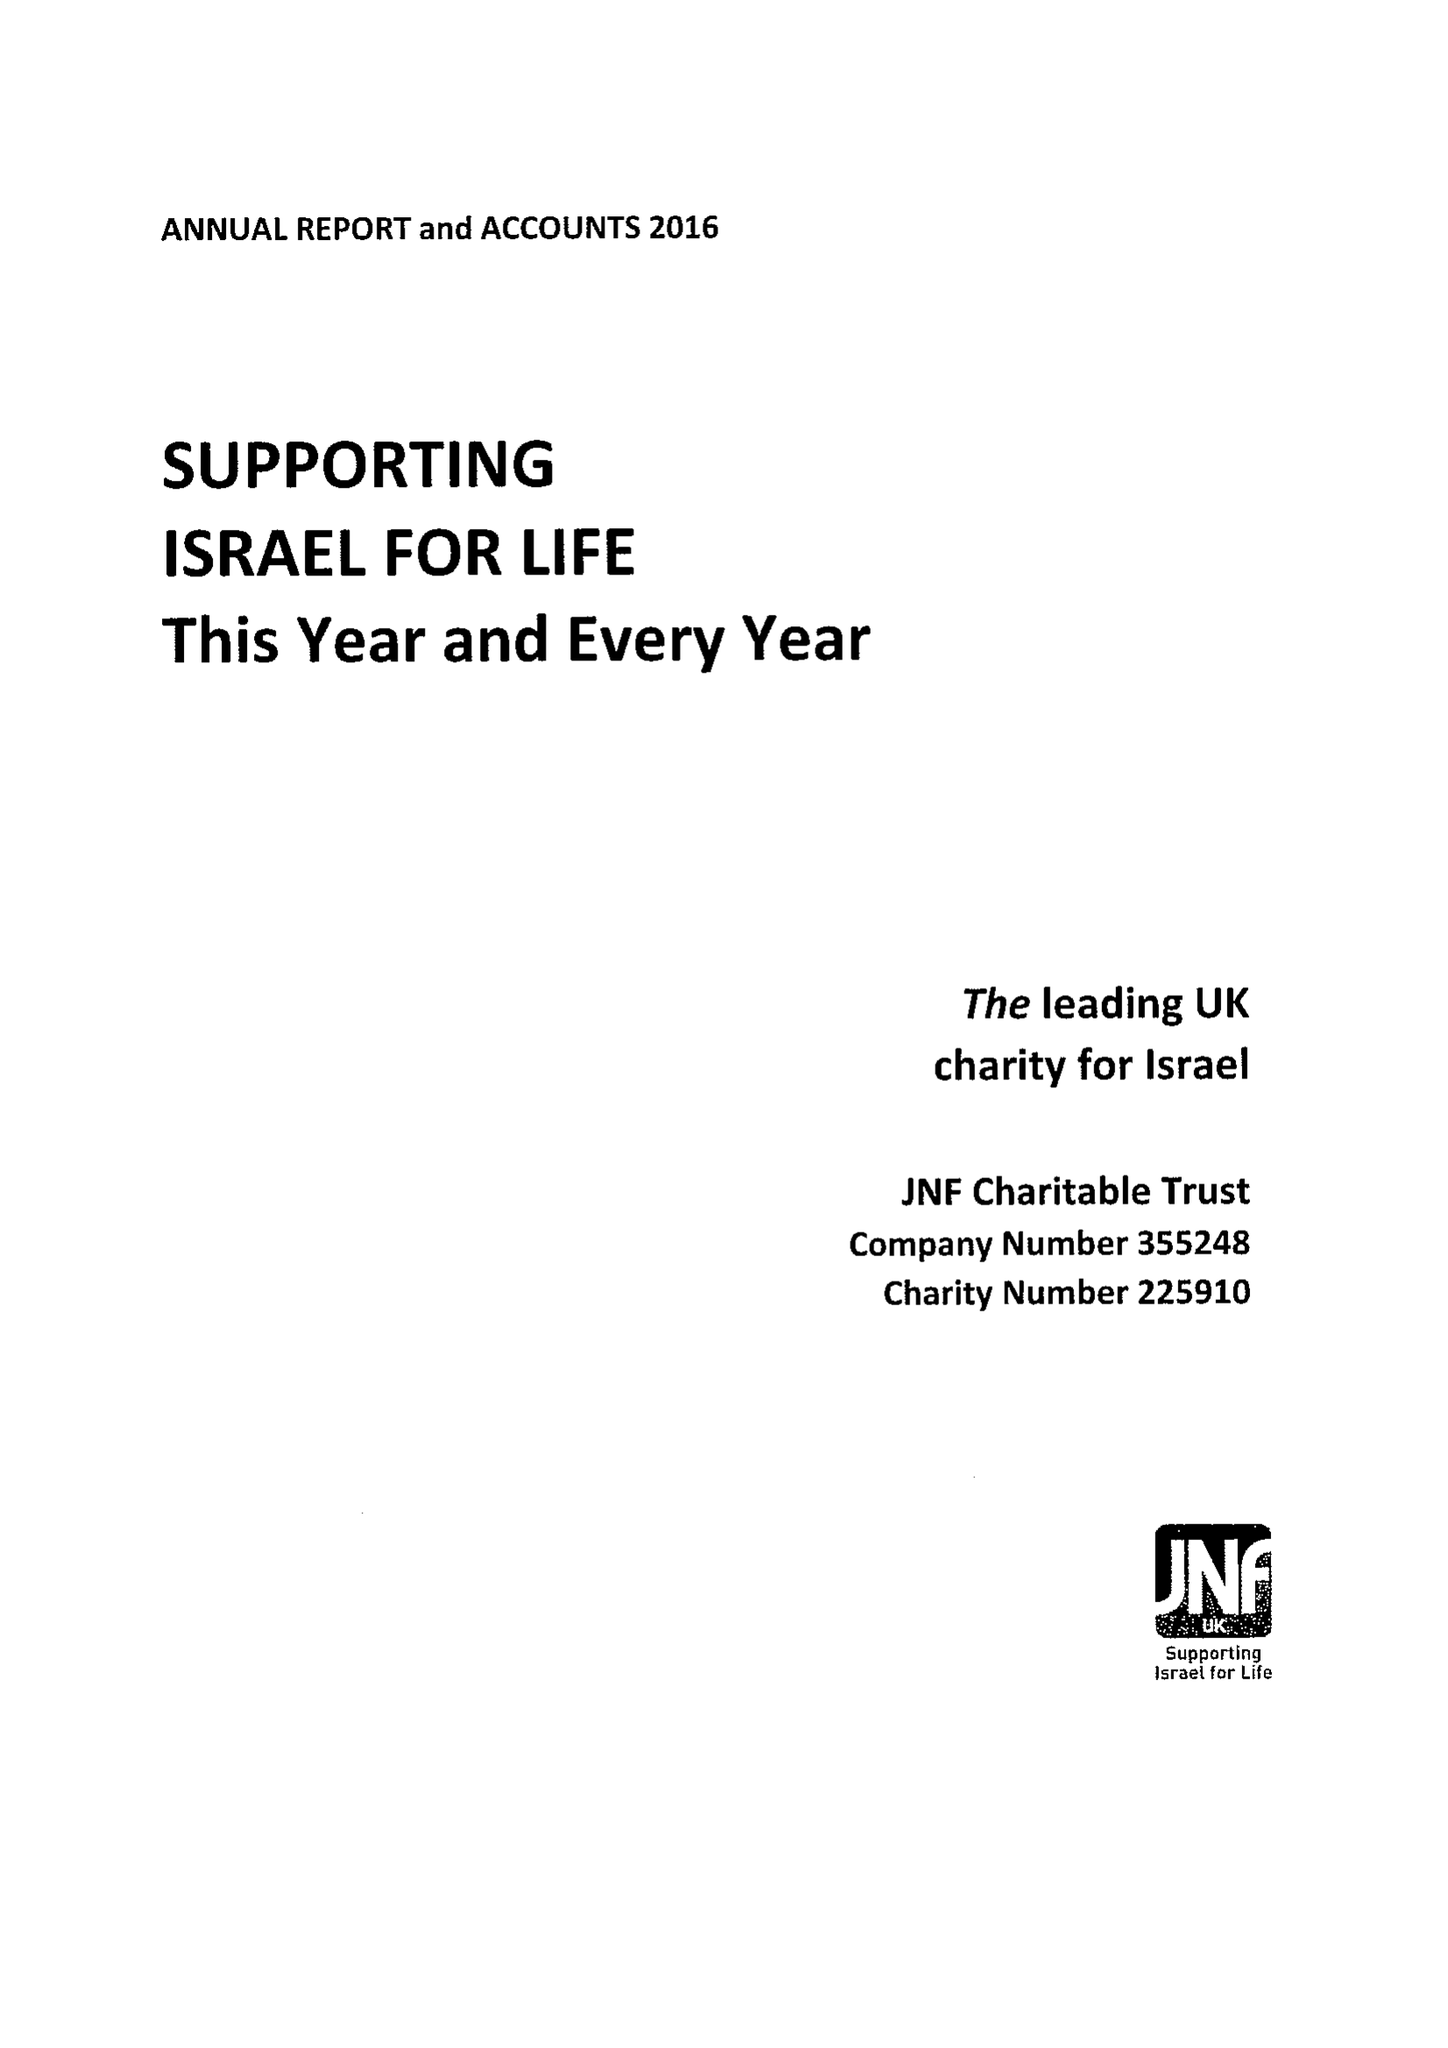What is the value for the income_annually_in_british_pounds?
Answer the question using a single word or phrase. 12417000.00 